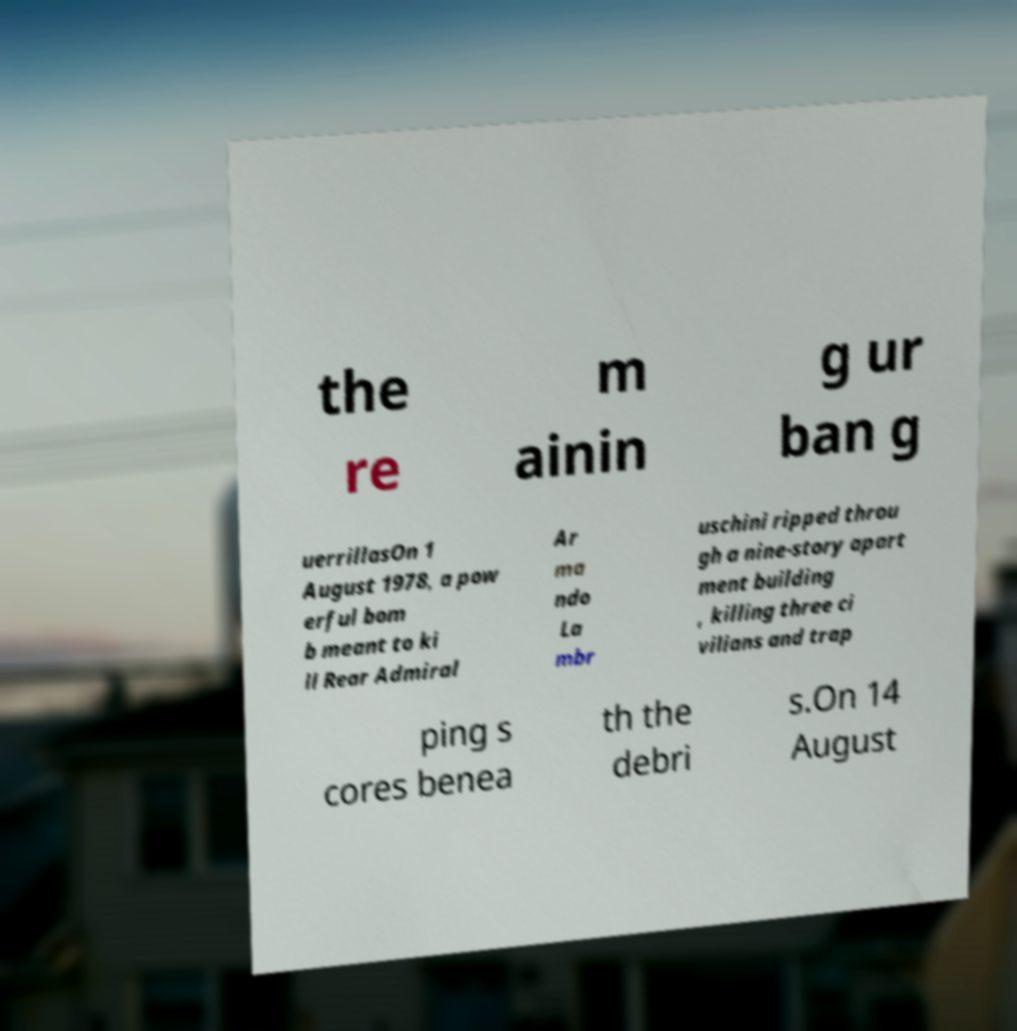Please read and relay the text visible in this image. What does it say? the re m ainin g ur ban g uerrillasOn 1 August 1978, a pow erful bom b meant to ki ll Rear Admiral Ar ma ndo La mbr uschini ripped throu gh a nine-story apart ment building , killing three ci vilians and trap ping s cores benea th the debri s.On 14 August 